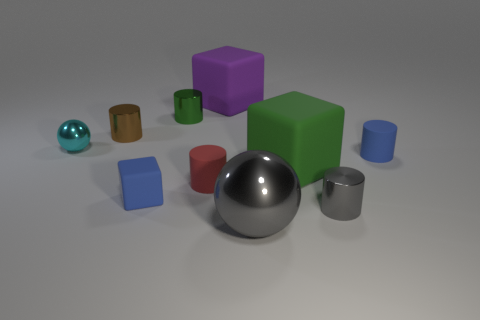Do the ball on the left side of the blue cube and the gray ball have the same material?
Keep it short and to the point. Yes. What is the size of the blue rubber cylinder?
Your answer should be compact. Small. What is the shape of the tiny rubber object that is the same color as the small cube?
Your response must be concise. Cylinder. What number of balls are either small blue rubber things or small cyan metal things?
Make the answer very short. 1. Are there the same number of small cyan metal spheres that are on the right side of the big green matte thing and small brown things that are on the right side of the cyan ball?
Your answer should be compact. No. The gray object that is the same shape as the brown thing is what size?
Give a very brief answer. Small. How big is the thing that is both right of the gray metallic sphere and in front of the small rubber cube?
Ensure brevity in your answer.  Small. Are there any tiny blue matte things in front of the tiny red cylinder?
Keep it short and to the point. Yes. How many objects are red rubber things that are right of the small cyan thing or gray rubber cylinders?
Your answer should be compact. 1. How many red matte objects are in front of the cylinder to the left of the tiny matte block?
Provide a short and direct response. 1. 